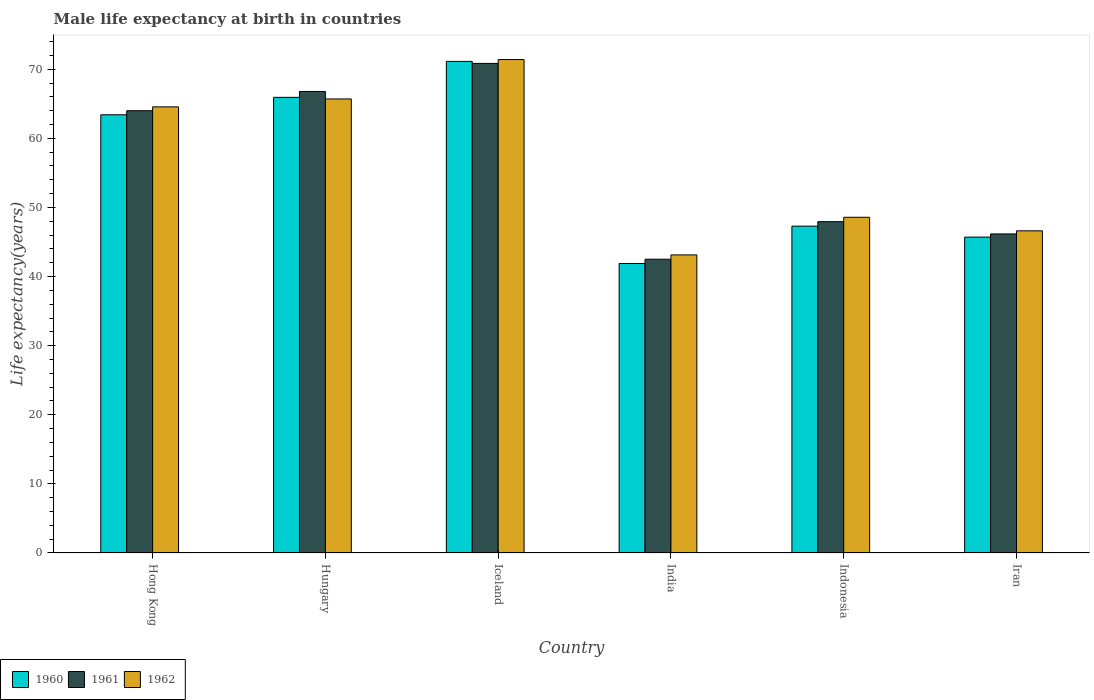How many groups of bars are there?
Offer a very short reply. 6. Are the number of bars per tick equal to the number of legend labels?
Your answer should be very brief. Yes. Are the number of bars on each tick of the X-axis equal?
Provide a succinct answer. Yes. How many bars are there on the 5th tick from the left?
Your answer should be very brief. 3. What is the label of the 1st group of bars from the left?
Make the answer very short. Hong Kong. What is the male life expectancy at birth in 1962 in Hong Kong?
Provide a short and direct response. 64.55. Across all countries, what is the maximum male life expectancy at birth in 1961?
Your answer should be very brief. 70.84. Across all countries, what is the minimum male life expectancy at birth in 1962?
Provide a short and direct response. 43.13. In which country was the male life expectancy at birth in 1960 maximum?
Provide a short and direct response. Iceland. What is the total male life expectancy at birth in 1960 in the graph?
Your response must be concise. 335.36. What is the difference between the male life expectancy at birth in 1960 in Iceland and that in Iran?
Provide a short and direct response. 25.43. What is the difference between the male life expectancy at birth in 1961 in India and the male life expectancy at birth in 1962 in Hong Kong?
Make the answer very short. -22.04. What is the average male life expectancy at birth in 1961 per country?
Your response must be concise. 56.37. What is the difference between the male life expectancy at birth of/in 1960 and male life expectancy at birth of/in 1961 in Iceland?
Ensure brevity in your answer.  0.3. What is the ratio of the male life expectancy at birth in 1961 in Iceland to that in Indonesia?
Provide a short and direct response. 1.48. What is the difference between the highest and the second highest male life expectancy at birth in 1960?
Give a very brief answer. 2.52. What is the difference between the highest and the lowest male life expectancy at birth in 1960?
Offer a very short reply. 29.25. In how many countries, is the male life expectancy at birth in 1962 greater than the average male life expectancy at birth in 1962 taken over all countries?
Make the answer very short. 3. Is the sum of the male life expectancy at birth in 1961 in Hong Kong and India greater than the maximum male life expectancy at birth in 1962 across all countries?
Provide a succinct answer. Yes. What does the 2nd bar from the left in India represents?
Keep it short and to the point. 1961. Is it the case that in every country, the sum of the male life expectancy at birth in 1962 and male life expectancy at birth in 1960 is greater than the male life expectancy at birth in 1961?
Offer a very short reply. Yes. How many countries are there in the graph?
Offer a terse response. 6. Does the graph contain grids?
Offer a terse response. No. How many legend labels are there?
Your answer should be compact. 3. How are the legend labels stacked?
Your answer should be compact. Horizontal. What is the title of the graph?
Ensure brevity in your answer.  Male life expectancy at birth in countries. What is the label or title of the Y-axis?
Keep it short and to the point. Life expectancy(years). What is the Life expectancy(years) in 1960 in Hong Kong?
Give a very brief answer. 63.41. What is the Life expectancy(years) of 1961 in Hong Kong?
Offer a terse response. 63.99. What is the Life expectancy(years) of 1962 in Hong Kong?
Offer a terse response. 64.55. What is the Life expectancy(years) in 1960 in Hungary?
Offer a very short reply. 65.93. What is the Life expectancy(years) of 1961 in Hungary?
Provide a short and direct response. 66.78. What is the Life expectancy(years) in 1962 in Hungary?
Provide a short and direct response. 65.7. What is the Life expectancy(years) of 1960 in Iceland?
Give a very brief answer. 71.14. What is the Life expectancy(years) of 1961 in Iceland?
Ensure brevity in your answer.  70.84. What is the Life expectancy(years) of 1962 in Iceland?
Keep it short and to the point. 71.4. What is the Life expectancy(years) of 1960 in India?
Provide a short and direct response. 41.89. What is the Life expectancy(years) in 1961 in India?
Give a very brief answer. 42.51. What is the Life expectancy(years) in 1962 in India?
Ensure brevity in your answer.  43.13. What is the Life expectancy(years) in 1960 in Indonesia?
Provide a succinct answer. 47.29. What is the Life expectancy(years) in 1961 in Indonesia?
Offer a terse response. 47.94. What is the Life expectancy(years) in 1962 in Indonesia?
Offer a very short reply. 48.58. What is the Life expectancy(years) in 1960 in Iran?
Give a very brief answer. 45.71. What is the Life expectancy(years) of 1961 in Iran?
Make the answer very short. 46.17. What is the Life expectancy(years) of 1962 in Iran?
Provide a succinct answer. 46.62. Across all countries, what is the maximum Life expectancy(years) of 1960?
Offer a terse response. 71.14. Across all countries, what is the maximum Life expectancy(years) of 1961?
Provide a short and direct response. 70.84. Across all countries, what is the maximum Life expectancy(years) in 1962?
Give a very brief answer. 71.4. Across all countries, what is the minimum Life expectancy(years) of 1960?
Make the answer very short. 41.89. Across all countries, what is the minimum Life expectancy(years) in 1961?
Your response must be concise. 42.51. Across all countries, what is the minimum Life expectancy(years) of 1962?
Your answer should be compact. 43.13. What is the total Life expectancy(years) in 1960 in the graph?
Provide a succinct answer. 335.36. What is the total Life expectancy(years) of 1961 in the graph?
Give a very brief answer. 338.23. What is the total Life expectancy(years) in 1962 in the graph?
Offer a terse response. 339.98. What is the difference between the Life expectancy(years) in 1960 in Hong Kong and that in Hungary?
Offer a terse response. -2.52. What is the difference between the Life expectancy(years) of 1961 in Hong Kong and that in Hungary?
Offer a terse response. -2.79. What is the difference between the Life expectancy(years) in 1962 in Hong Kong and that in Hungary?
Ensure brevity in your answer.  -1.15. What is the difference between the Life expectancy(years) of 1960 in Hong Kong and that in Iceland?
Give a very brief answer. -7.73. What is the difference between the Life expectancy(years) of 1961 in Hong Kong and that in Iceland?
Provide a succinct answer. -6.85. What is the difference between the Life expectancy(years) in 1962 in Hong Kong and that in Iceland?
Keep it short and to the point. -6.85. What is the difference between the Life expectancy(years) of 1960 in Hong Kong and that in India?
Ensure brevity in your answer.  21.52. What is the difference between the Life expectancy(years) of 1961 in Hong Kong and that in India?
Offer a terse response. 21.48. What is the difference between the Life expectancy(years) of 1962 in Hong Kong and that in India?
Your answer should be very brief. 21.42. What is the difference between the Life expectancy(years) of 1960 in Hong Kong and that in Indonesia?
Your answer should be very brief. 16.11. What is the difference between the Life expectancy(years) in 1961 in Hong Kong and that in Indonesia?
Provide a short and direct response. 16.05. What is the difference between the Life expectancy(years) of 1962 in Hong Kong and that in Indonesia?
Provide a short and direct response. 15.98. What is the difference between the Life expectancy(years) of 1960 in Hong Kong and that in Iran?
Your response must be concise. 17.7. What is the difference between the Life expectancy(years) of 1961 in Hong Kong and that in Iran?
Your answer should be compact. 17.83. What is the difference between the Life expectancy(years) in 1962 in Hong Kong and that in Iran?
Provide a short and direct response. 17.94. What is the difference between the Life expectancy(years) of 1960 in Hungary and that in Iceland?
Offer a very short reply. -5.21. What is the difference between the Life expectancy(years) of 1961 in Hungary and that in Iceland?
Your response must be concise. -4.06. What is the difference between the Life expectancy(years) in 1962 in Hungary and that in Iceland?
Offer a terse response. -5.7. What is the difference between the Life expectancy(years) of 1960 in Hungary and that in India?
Your answer should be very brief. 24.04. What is the difference between the Life expectancy(years) of 1961 in Hungary and that in India?
Your answer should be very brief. 24.27. What is the difference between the Life expectancy(years) in 1962 in Hungary and that in India?
Provide a short and direct response. 22.57. What is the difference between the Life expectancy(years) in 1960 in Hungary and that in Indonesia?
Make the answer very short. 18.64. What is the difference between the Life expectancy(years) in 1961 in Hungary and that in Indonesia?
Keep it short and to the point. 18.84. What is the difference between the Life expectancy(years) in 1962 in Hungary and that in Indonesia?
Ensure brevity in your answer.  17.12. What is the difference between the Life expectancy(years) of 1960 in Hungary and that in Iran?
Give a very brief answer. 20.22. What is the difference between the Life expectancy(years) of 1961 in Hungary and that in Iran?
Your answer should be compact. 20.61. What is the difference between the Life expectancy(years) in 1962 in Hungary and that in Iran?
Ensure brevity in your answer.  19.08. What is the difference between the Life expectancy(years) of 1960 in Iceland and that in India?
Offer a terse response. 29.25. What is the difference between the Life expectancy(years) of 1961 in Iceland and that in India?
Make the answer very short. 28.33. What is the difference between the Life expectancy(years) of 1962 in Iceland and that in India?
Your response must be concise. 28.27. What is the difference between the Life expectancy(years) of 1960 in Iceland and that in Indonesia?
Provide a succinct answer. 23.84. What is the difference between the Life expectancy(years) of 1961 in Iceland and that in Indonesia?
Offer a very short reply. 22.9. What is the difference between the Life expectancy(years) in 1962 in Iceland and that in Indonesia?
Provide a short and direct response. 22.82. What is the difference between the Life expectancy(years) of 1960 in Iceland and that in Iran?
Keep it short and to the point. 25.43. What is the difference between the Life expectancy(years) in 1961 in Iceland and that in Iran?
Give a very brief answer. 24.67. What is the difference between the Life expectancy(years) of 1962 in Iceland and that in Iran?
Offer a terse response. 24.78. What is the difference between the Life expectancy(years) of 1960 in India and that in Indonesia?
Offer a terse response. -5.4. What is the difference between the Life expectancy(years) of 1961 in India and that in Indonesia?
Offer a very short reply. -5.43. What is the difference between the Life expectancy(years) in 1962 in India and that in Indonesia?
Give a very brief answer. -5.44. What is the difference between the Life expectancy(years) of 1960 in India and that in Iran?
Make the answer very short. -3.82. What is the difference between the Life expectancy(years) in 1961 in India and that in Iran?
Offer a very short reply. -3.66. What is the difference between the Life expectancy(years) of 1962 in India and that in Iran?
Keep it short and to the point. -3.48. What is the difference between the Life expectancy(years) in 1960 in Indonesia and that in Iran?
Provide a short and direct response. 1.59. What is the difference between the Life expectancy(years) of 1961 in Indonesia and that in Iran?
Ensure brevity in your answer.  1.77. What is the difference between the Life expectancy(years) of 1962 in Indonesia and that in Iran?
Your response must be concise. 1.96. What is the difference between the Life expectancy(years) of 1960 in Hong Kong and the Life expectancy(years) of 1961 in Hungary?
Your answer should be very brief. -3.37. What is the difference between the Life expectancy(years) of 1960 in Hong Kong and the Life expectancy(years) of 1962 in Hungary?
Give a very brief answer. -2.29. What is the difference between the Life expectancy(years) in 1961 in Hong Kong and the Life expectancy(years) in 1962 in Hungary?
Ensure brevity in your answer.  -1.71. What is the difference between the Life expectancy(years) of 1960 in Hong Kong and the Life expectancy(years) of 1961 in Iceland?
Keep it short and to the point. -7.43. What is the difference between the Life expectancy(years) of 1960 in Hong Kong and the Life expectancy(years) of 1962 in Iceland?
Make the answer very short. -7.99. What is the difference between the Life expectancy(years) in 1961 in Hong Kong and the Life expectancy(years) in 1962 in Iceland?
Your answer should be very brief. -7.41. What is the difference between the Life expectancy(years) of 1960 in Hong Kong and the Life expectancy(years) of 1961 in India?
Offer a very short reply. 20.9. What is the difference between the Life expectancy(years) in 1960 in Hong Kong and the Life expectancy(years) in 1962 in India?
Your answer should be very brief. 20.27. What is the difference between the Life expectancy(years) of 1961 in Hong Kong and the Life expectancy(years) of 1962 in India?
Give a very brief answer. 20.86. What is the difference between the Life expectancy(years) in 1960 in Hong Kong and the Life expectancy(years) in 1961 in Indonesia?
Your answer should be compact. 15.47. What is the difference between the Life expectancy(years) in 1960 in Hong Kong and the Life expectancy(years) in 1962 in Indonesia?
Your response must be concise. 14.83. What is the difference between the Life expectancy(years) in 1961 in Hong Kong and the Life expectancy(years) in 1962 in Indonesia?
Your response must be concise. 15.42. What is the difference between the Life expectancy(years) of 1960 in Hong Kong and the Life expectancy(years) of 1961 in Iran?
Provide a short and direct response. 17.24. What is the difference between the Life expectancy(years) in 1960 in Hong Kong and the Life expectancy(years) in 1962 in Iran?
Offer a very short reply. 16.79. What is the difference between the Life expectancy(years) in 1961 in Hong Kong and the Life expectancy(years) in 1962 in Iran?
Ensure brevity in your answer.  17.38. What is the difference between the Life expectancy(years) of 1960 in Hungary and the Life expectancy(years) of 1961 in Iceland?
Your response must be concise. -4.91. What is the difference between the Life expectancy(years) in 1960 in Hungary and the Life expectancy(years) in 1962 in Iceland?
Offer a terse response. -5.47. What is the difference between the Life expectancy(years) of 1961 in Hungary and the Life expectancy(years) of 1962 in Iceland?
Your response must be concise. -4.62. What is the difference between the Life expectancy(years) in 1960 in Hungary and the Life expectancy(years) in 1961 in India?
Provide a succinct answer. 23.42. What is the difference between the Life expectancy(years) of 1960 in Hungary and the Life expectancy(years) of 1962 in India?
Ensure brevity in your answer.  22.8. What is the difference between the Life expectancy(years) in 1961 in Hungary and the Life expectancy(years) in 1962 in India?
Your response must be concise. 23.65. What is the difference between the Life expectancy(years) of 1960 in Hungary and the Life expectancy(years) of 1961 in Indonesia?
Make the answer very short. 17.99. What is the difference between the Life expectancy(years) of 1960 in Hungary and the Life expectancy(years) of 1962 in Indonesia?
Keep it short and to the point. 17.35. What is the difference between the Life expectancy(years) of 1961 in Hungary and the Life expectancy(years) of 1962 in Indonesia?
Keep it short and to the point. 18.2. What is the difference between the Life expectancy(years) in 1960 in Hungary and the Life expectancy(years) in 1961 in Iran?
Your answer should be compact. 19.76. What is the difference between the Life expectancy(years) in 1960 in Hungary and the Life expectancy(years) in 1962 in Iran?
Give a very brief answer. 19.31. What is the difference between the Life expectancy(years) in 1961 in Hungary and the Life expectancy(years) in 1962 in Iran?
Keep it short and to the point. 20.16. What is the difference between the Life expectancy(years) of 1960 in Iceland and the Life expectancy(years) of 1961 in India?
Your response must be concise. 28.62. What is the difference between the Life expectancy(years) in 1960 in Iceland and the Life expectancy(years) in 1962 in India?
Provide a short and direct response. 28. What is the difference between the Life expectancy(years) of 1961 in Iceland and the Life expectancy(years) of 1962 in India?
Your answer should be very brief. 27.71. What is the difference between the Life expectancy(years) of 1960 in Iceland and the Life expectancy(years) of 1961 in Indonesia?
Offer a very short reply. 23.19. What is the difference between the Life expectancy(years) in 1960 in Iceland and the Life expectancy(years) in 1962 in Indonesia?
Provide a succinct answer. 22.56. What is the difference between the Life expectancy(years) of 1961 in Iceland and the Life expectancy(years) of 1962 in Indonesia?
Give a very brief answer. 22.26. What is the difference between the Life expectancy(years) of 1960 in Iceland and the Life expectancy(years) of 1961 in Iran?
Keep it short and to the point. 24.97. What is the difference between the Life expectancy(years) of 1960 in Iceland and the Life expectancy(years) of 1962 in Iran?
Your answer should be very brief. 24.52. What is the difference between the Life expectancy(years) in 1961 in Iceland and the Life expectancy(years) in 1962 in Iran?
Your response must be concise. 24.22. What is the difference between the Life expectancy(years) in 1960 in India and the Life expectancy(years) in 1961 in Indonesia?
Ensure brevity in your answer.  -6.05. What is the difference between the Life expectancy(years) in 1960 in India and the Life expectancy(years) in 1962 in Indonesia?
Offer a terse response. -6.69. What is the difference between the Life expectancy(years) in 1961 in India and the Life expectancy(years) in 1962 in Indonesia?
Ensure brevity in your answer.  -6.07. What is the difference between the Life expectancy(years) of 1960 in India and the Life expectancy(years) of 1961 in Iran?
Offer a terse response. -4.28. What is the difference between the Life expectancy(years) of 1960 in India and the Life expectancy(years) of 1962 in Iran?
Your answer should be compact. -4.73. What is the difference between the Life expectancy(years) in 1961 in India and the Life expectancy(years) in 1962 in Iran?
Offer a very short reply. -4.11. What is the difference between the Life expectancy(years) of 1960 in Indonesia and the Life expectancy(years) of 1961 in Iran?
Provide a succinct answer. 1.13. What is the difference between the Life expectancy(years) of 1960 in Indonesia and the Life expectancy(years) of 1962 in Iran?
Keep it short and to the point. 0.68. What is the difference between the Life expectancy(years) in 1961 in Indonesia and the Life expectancy(years) in 1962 in Iran?
Your answer should be compact. 1.32. What is the average Life expectancy(years) of 1960 per country?
Offer a terse response. 55.89. What is the average Life expectancy(years) in 1961 per country?
Provide a short and direct response. 56.37. What is the average Life expectancy(years) in 1962 per country?
Ensure brevity in your answer.  56.66. What is the difference between the Life expectancy(years) in 1960 and Life expectancy(years) in 1961 in Hong Kong?
Your response must be concise. -0.59. What is the difference between the Life expectancy(years) of 1960 and Life expectancy(years) of 1962 in Hong Kong?
Offer a terse response. -1.15. What is the difference between the Life expectancy(years) in 1961 and Life expectancy(years) in 1962 in Hong Kong?
Make the answer very short. -0.56. What is the difference between the Life expectancy(years) in 1960 and Life expectancy(years) in 1961 in Hungary?
Your answer should be compact. -0.85. What is the difference between the Life expectancy(years) of 1960 and Life expectancy(years) of 1962 in Hungary?
Your answer should be very brief. 0.23. What is the difference between the Life expectancy(years) of 1961 and Life expectancy(years) of 1962 in Hungary?
Keep it short and to the point. 1.08. What is the difference between the Life expectancy(years) in 1960 and Life expectancy(years) in 1961 in Iceland?
Your answer should be compact. 0.29. What is the difference between the Life expectancy(years) in 1960 and Life expectancy(years) in 1962 in Iceland?
Your response must be concise. -0.27. What is the difference between the Life expectancy(years) of 1961 and Life expectancy(years) of 1962 in Iceland?
Your answer should be very brief. -0.56. What is the difference between the Life expectancy(years) in 1960 and Life expectancy(years) in 1961 in India?
Provide a short and direct response. -0.62. What is the difference between the Life expectancy(years) of 1960 and Life expectancy(years) of 1962 in India?
Provide a succinct answer. -1.24. What is the difference between the Life expectancy(years) of 1961 and Life expectancy(years) of 1962 in India?
Your response must be concise. -0.62. What is the difference between the Life expectancy(years) of 1960 and Life expectancy(years) of 1961 in Indonesia?
Give a very brief answer. -0.65. What is the difference between the Life expectancy(years) in 1960 and Life expectancy(years) in 1962 in Indonesia?
Offer a terse response. -1.28. What is the difference between the Life expectancy(years) of 1961 and Life expectancy(years) of 1962 in Indonesia?
Ensure brevity in your answer.  -0.64. What is the difference between the Life expectancy(years) in 1960 and Life expectancy(years) in 1961 in Iran?
Your answer should be very brief. -0.46. What is the difference between the Life expectancy(years) of 1960 and Life expectancy(years) of 1962 in Iran?
Your answer should be compact. -0.91. What is the difference between the Life expectancy(years) in 1961 and Life expectancy(years) in 1962 in Iran?
Provide a short and direct response. -0.45. What is the ratio of the Life expectancy(years) in 1960 in Hong Kong to that in Hungary?
Give a very brief answer. 0.96. What is the ratio of the Life expectancy(years) of 1961 in Hong Kong to that in Hungary?
Provide a short and direct response. 0.96. What is the ratio of the Life expectancy(years) of 1962 in Hong Kong to that in Hungary?
Your response must be concise. 0.98. What is the ratio of the Life expectancy(years) of 1960 in Hong Kong to that in Iceland?
Your response must be concise. 0.89. What is the ratio of the Life expectancy(years) in 1961 in Hong Kong to that in Iceland?
Make the answer very short. 0.9. What is the ratio of the Life expectancy(years) in 1962 in Hong Kong to that in Iceland?
Offer a terse response. 0.9. What is the ratio of the Life expectancy(years) of 1960 in Hong Kong to that in India?
Provide a short and direct response. 1.51. What is the ratio of the Life expectancy(years) of 1961 in Hong Kong to that in India?
Provide a short and direct response. 1.51. What is the ratio of the Life expectancy(years) of 1962 in Hong Kong to that in India?
Your response must be concise. 1.5. What is the ratio of the Life expectancy(years) of 1960 in Hong Kong to that in Indonesia?
Offer a terse response. 1.34. What is the ratio of the Life expectancy(years) of 1961 in Hong Kong to that in Indonesia?
Offer a very short reply. 1.33. What is the ratio of the Life expectancy(years) of 1962 in Hong Kong to that in Indonesia?
Ensure brevity in your answer.  1.33. What is the ratio of the Life expectancy(years) in 1960 in Hong Kong to that in Iran?
Give a very brief answer. 1.39. What is the ratio of the Life expectancy(years) of 1961 in Hong Kong to that in Iran?
Provide a short and direct response. 1.39. What is the ratio of the Life expectancy(years) in 1962 in Hong Kong to that in Iran?
Give a very brief answer. 1.38. What is the ratio of the Life expectancy(years) in 1960 in Hungary to that in Iceland?
Make the answer very short. 0.93. What is the ratio of the Life expectancy(years) in 1961 in Hungary to that in Iceland?
Your response must be concise. 0.94. What is the ratio of the Life expectancy(years) in 1962 in Hungary to that in Iceland?
Ensure brevity in your answer.  0.92. What is the ratio of the Life expectancy(years) of 1960 in Hungary to that in India?
Provide a short and direct response. 1.57. What is the ratio of the Life expectancy(years) in 1961 in Hungary to that in India?
Your answer should be very brief. 1.57. What is the ratio of the Life expectancy(years) of 1962 in Hungary to that in India?
Provide a succinct answer. 1.52. What is the ratio of the Life expectancy(years) in 1960 in Hungary to that in Indonesia?
Your answer should be very brief. 1.39. What is the ratio of the Life expectancy(years) in 1961 in Hungary to that in Indonesia?
Make the answer very short. 1.39. What is the ratio of the Life expectancy(years) in 1962 in Hungary to that in Indonesia?
Offer a terse response. 1.35. What is the ratio of the Life expectancy(years) in 1960 in Hungary to that in Iran?
Keep it short and to the point. 1.44. What is the ratio of the Life expectancy(years) of 1961 in Hungary to that in Iran?
Provide a succinct answer. 1.45. What is the ratio of the Life expectancy(years) of 1962 in Hungary to that in Iran?
Provide a succinct answer. 1.41. What is the ratio of the Life expectancy(years) in 1960 in Iceland to that in India?
Provide a short and direct response. 1.7. What is the ratio of the Life expectancy(years) of 1961 in Iceland to that in India?
Your answer should be compact. 1.67. What is the ratio of the Life expectancy(years) of 1962 in Iceland to that in India?
Your answer should be very brief. 1.66. What is the ratio of the Life expectancy(years) in 1960 in Iceland to that in Indonesia?
Your answer should be compact. 1.5. What is the ratio of the Life expectancy(years) in 1961 in Iceland to that in Indonesia?
Provide a short and direct response. 1.48. What is the ratio of the Life expectancy(years) in 1962 in Iceland to that in Indonesia?
Offer a very short reply. 1.47. What is the ratio of the Life expectancy(years) in 1960 in Iceland to that in Iran?
Your answer should be very brief. 1.56. What is the ratio of the Life expectancy(years) in 1961 in Iceland to that in Iran?
Offer a terse response. 1.53. What is the ratio of the Life expectancy(years) of 1962 in Iceland to that in Iran?
Your answer should be very brief. 1.53. What is the ratio of the Life expectancy(years) of 1960 in India to that in Indonesia?
Your answer should be very brief. 0.89. What is the ratio of the Life expectancy(years) in 1961 in India to that in Indonesia?
Your answer should be very brief. 0.89. What is the ratio of the Life expectancy(years) in 1962 in India to that in Indonesia?
Your answer should be compact. 0.89. What is the ratio of the Life expectancy(years) of 1960 in India to that in Iran?
Your answer should be very brief. 0.92. What is the ratio of the Life expectancy(years) of 1961 in India to that in Iran?
Provide a succinct answer. 0.92. What is the ratio of the Life expectancy(years) in 1962 in India to that in Iran?
Offer a terse response. 0.93. What is the ratio of the Life expectancy(years) of 1960 in Indonesia to that in Iran?
Make the answer very short. 1.03. What is the ratio of the Life expectancy(years) in 1961 in Indonesia to that in Iran?
Provide a succinct answer. 1.04. What is the ratio of the Life expectancy(years) of 1962 in Indonesia to that in Iran?
Keep it short and to the point. 1.04. What is the difference between the highest and the second highest Life expectancy(years) of 1960?
Your answer should be compact. 5.21. What is the difference between the highest and the second highest Life expectancy(years) in 1961?
Ensure brevity in your answer.  4.06. What is the difference between the highest and the second highest Life expectancy(years) in 1962?
Ensure brevity in your answer.  5.7. What is the difference between the highest and the lowest Life expectancy(years) of 1960?
Your response must be concise. 29.25. What is the difference between the highest and the lowest Life expectancy(years) of 1961?
Keep it short and to the point. 28.33. What is the difference between the highest and the lowest Life expectancy(years) of 1962?
Your answer should be very brief. 28.27. 